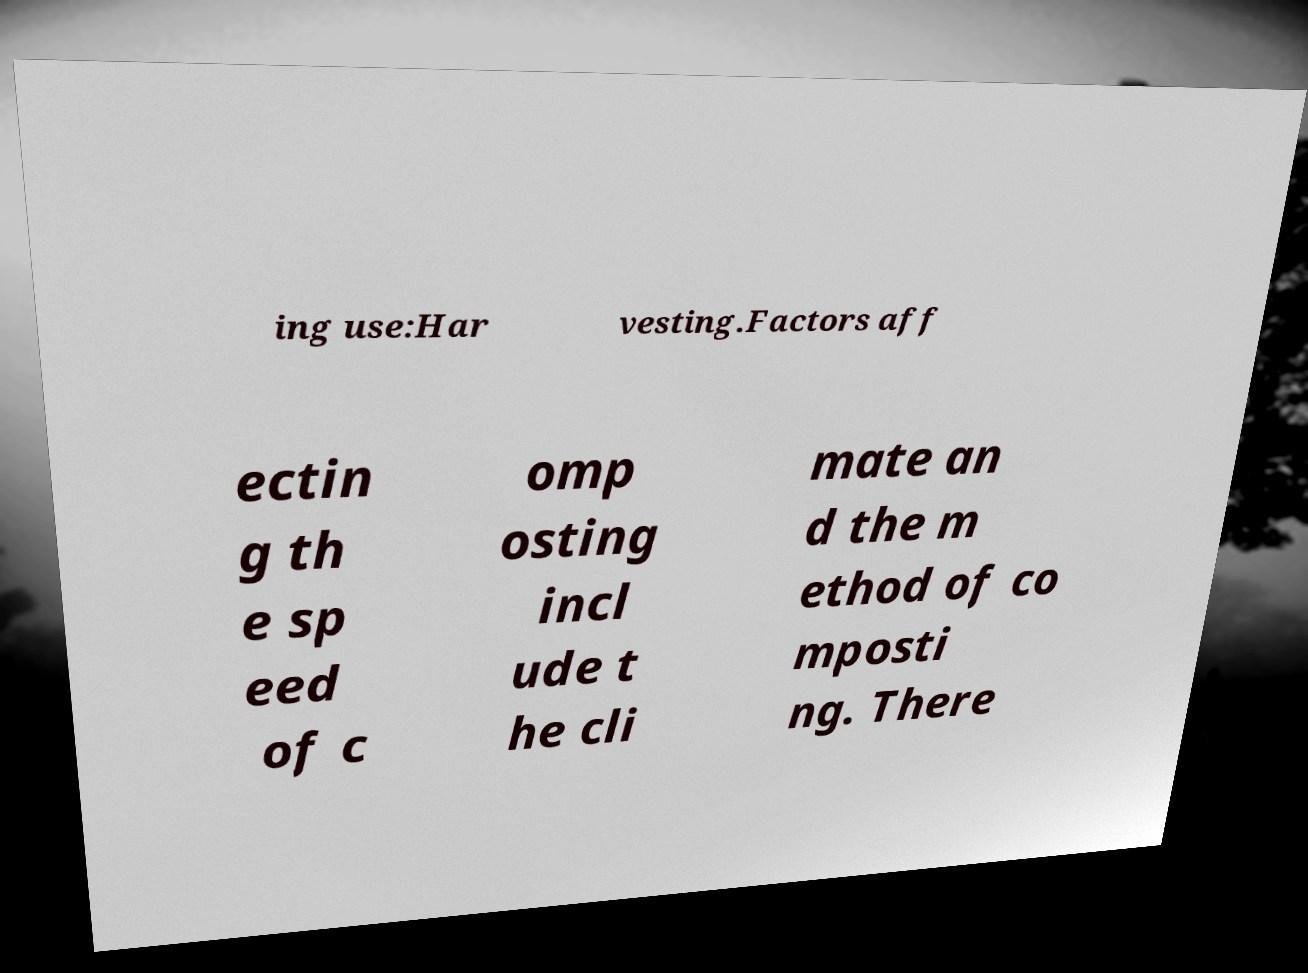Can you accurately transcribe the text from the provided image for me? ing use:Har vesting.Factors aff ectin g th e sp eed of c omp osting incl ude t he cli mate an d the m ethod of co mposti ng. There 